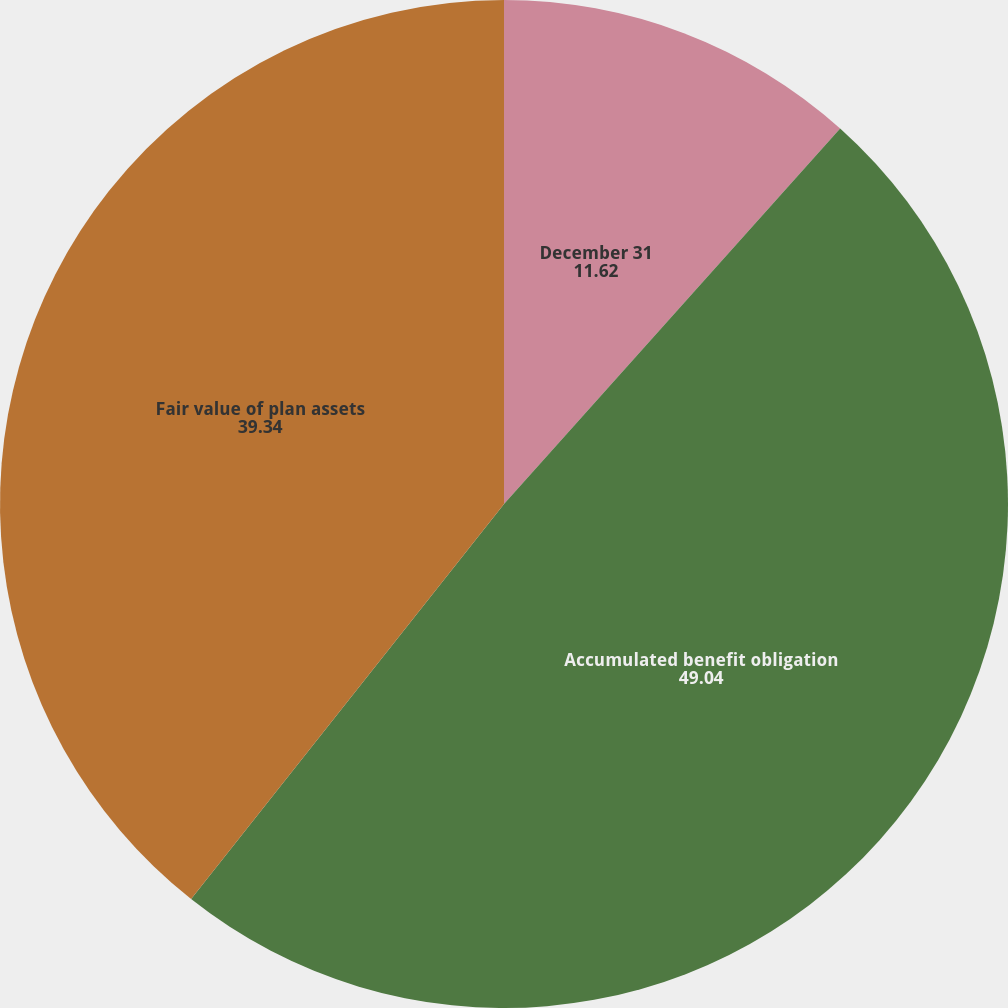Convert chart. <chart><loc_0><loc_0><loc_500><loc_500><pie_chart><fcel>December 31<fcel>Accumulated benefit obligation<fcel>Fair value of plan assets<nl><fcel>11.62%<fcel>49.04%<fcel>39.34%<nl></chart> 